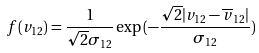<formula> <loc_0><loc_0><loc_500><loc_500>f ( v _ { 1 2 } ) = \frac { 1 } { \sqrt { 2 } \sigma _ { 1 2 } } \exp { ( - \frac { \sqrt { 2 } | v _ { 1 2 } - \overline { v } _ { 1 2 } | } { \sigma _ { 1 2 } } ) }</formula> 